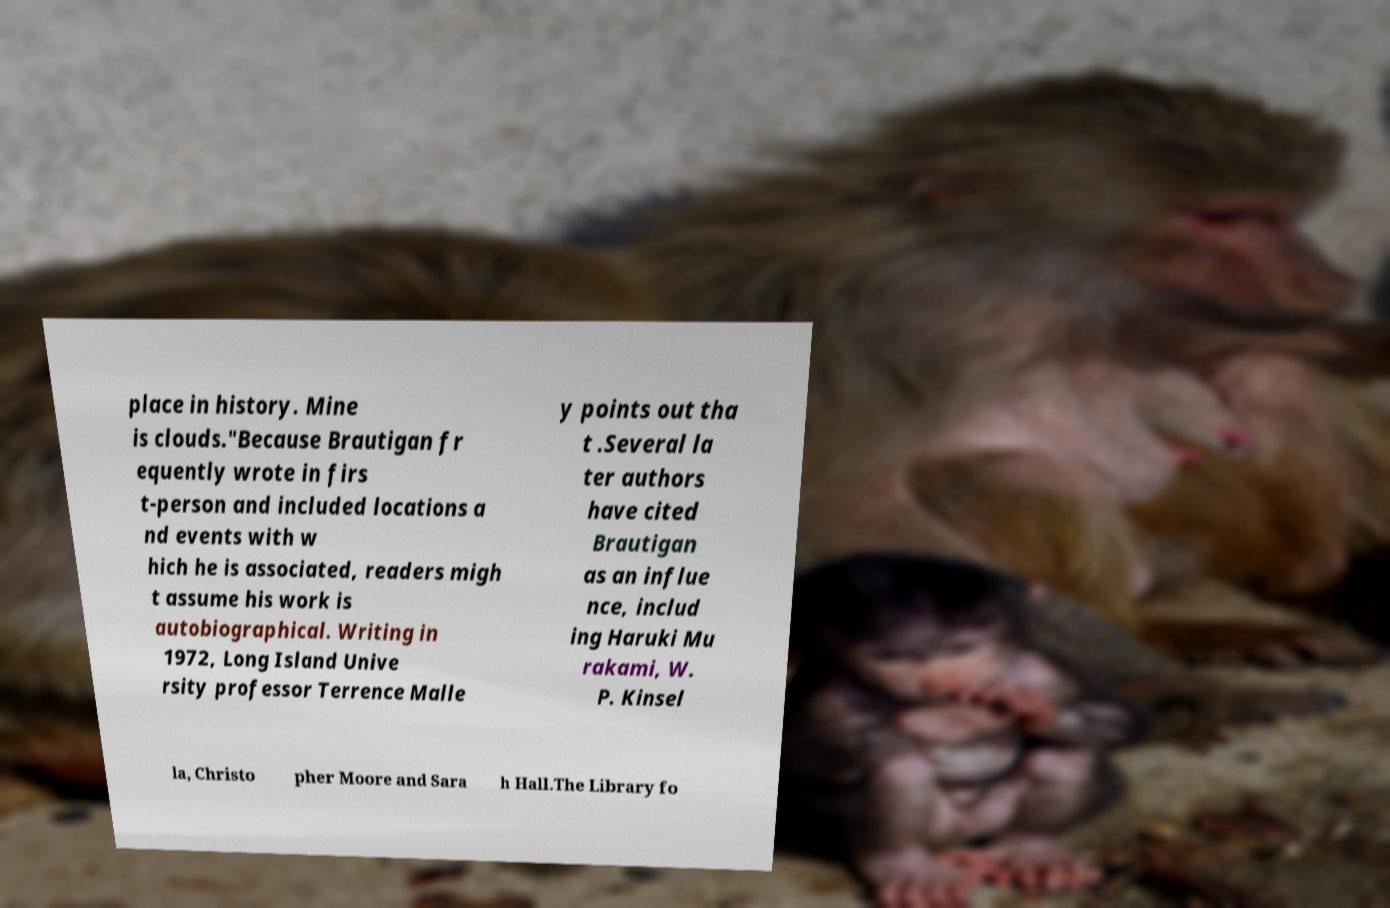Can you read and provide the text displayed in the image?This photo seems to have some interesting text. Can you extract and type it out for me? place in history. Mine is clouds."Because Brautigan fr equently wrote in firs t-person and included locations a nd events with w hich he is associated, readers migh t assume his work is autobiographical. Writing in 1972, Long Island Unive rsity professor Terrence Malle y points out tha t .Several la ter authors have cited Brautigan as an influe nce, includ ing Haruki Mu rakami, W. P. Kinsel la, Christo pher Moore and Sara h Hall.The Library fo 